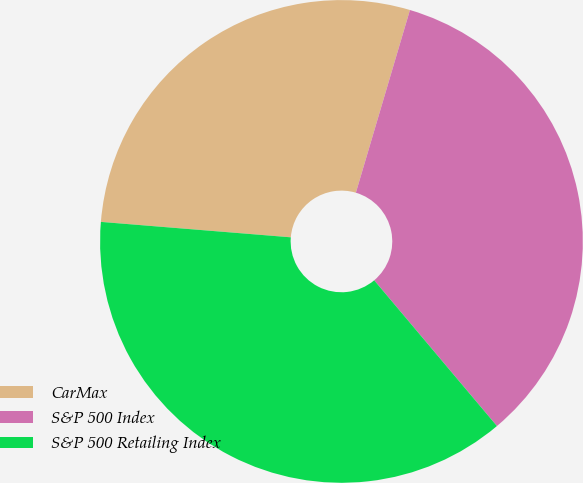<chart> <loc_0><loc_0><loc_500><loc_500><pie_chart><fcel>CarMax<fcel>S&P 500 Index<fcel>S&P 500 Retailing Index<nl><fcel>28.29%<fcel>34.28%<fcel>37.43%<nl></chart> 